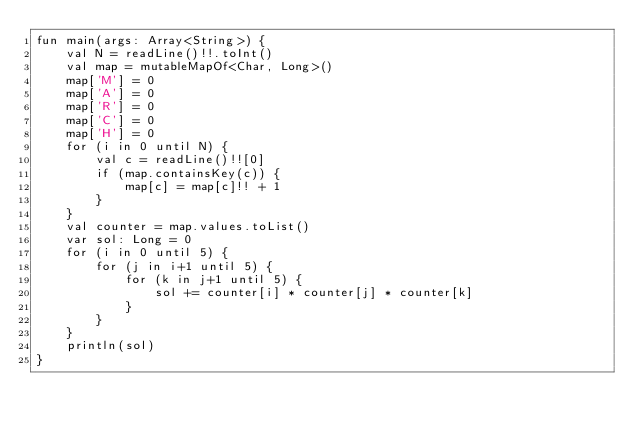Convert code to text. <code><loc_0><loc_0><loc_500><loc_500><_Kotlin_>fun main(args: Array<String>) {
    val N = readLine()!!.toInt()
    val map = mutableMapOf<Char, Long>()
    map['M'] = 0
    map['A'] = 0
    map['R'] = 0
    map['C'] = 0
    map['H'] = 0
    for (i in 0 until N) {
        val c = readLine()!![0]
        if (map.containsKey(c)) {
            map[c] = map[c]!! + 1
        }
    }
    val counter = map.values.toList()
    var sol: Long = 0
    for (i in 0 until 5) {
        for (j in i+1 until 5) {
            for (k in j+1 until 5) {
                sol += counter[i] * counter[j] * counter[k]
            }
        }
    }
    println(sol)
}</code> 